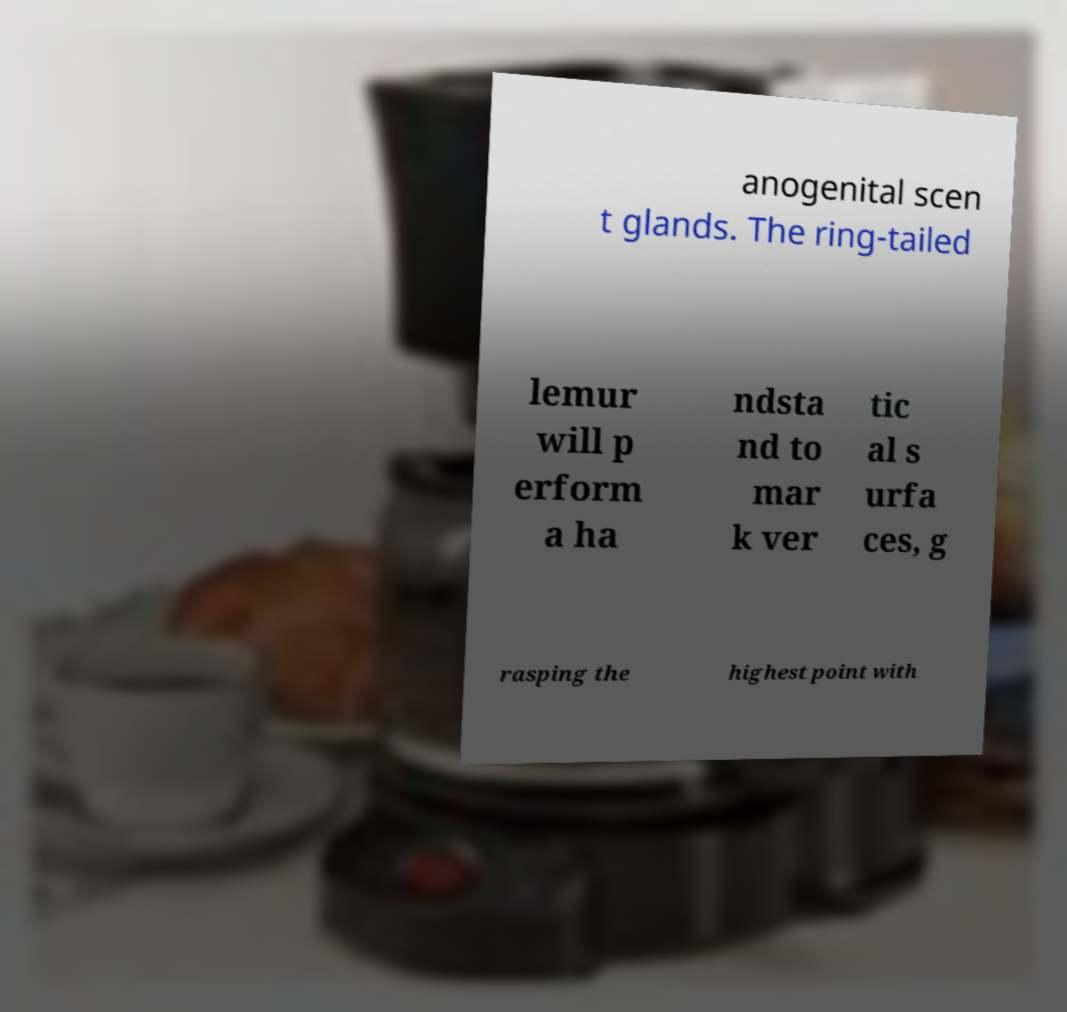For documentation purposes, I need the text within this image transcribed. Could you provide that? anogenital scen t glands. The ring-tailed lemur will p erform a ha ndsta nd to mar k ver tic al s urfa ces, g rasping the highest point with 